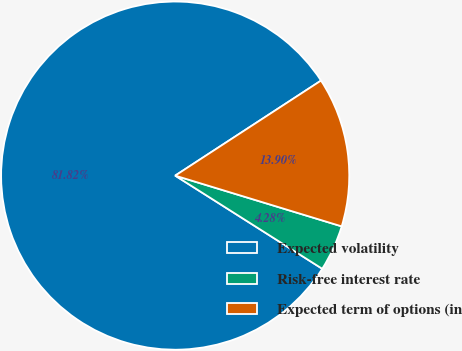<chart> <loc_0><loc_0><loc_500><loc_500><pie_chart><fcel>Expected volatility<fcel>Risk-free interest rate<fcel>Expected term of options (in<nl><fcel>81.82%<fcel>4.28%<fcel>13.9%<nl></chart> 